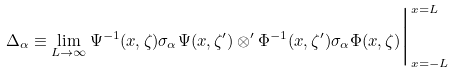Convert formula to latex. <formula><loc_0><loc_0><loc_500><loc_500>\Delta _ { \alpha } \equiv \lim _ { L \to \infty } \Psi ^ { - 1 } ( x , \zeta ) \sigma _ { \alpha } \Psi ( x , \zeta ^ { \prime } ) \otimes ^ { \prime } \Phi ^ { - 1 } ( x , \zeta ^ { \prime } ) \sigma _ { \alpha } \Phi ( x , \zeta ) \Big | _ { x = - L } ^ { x = L }</formula> 